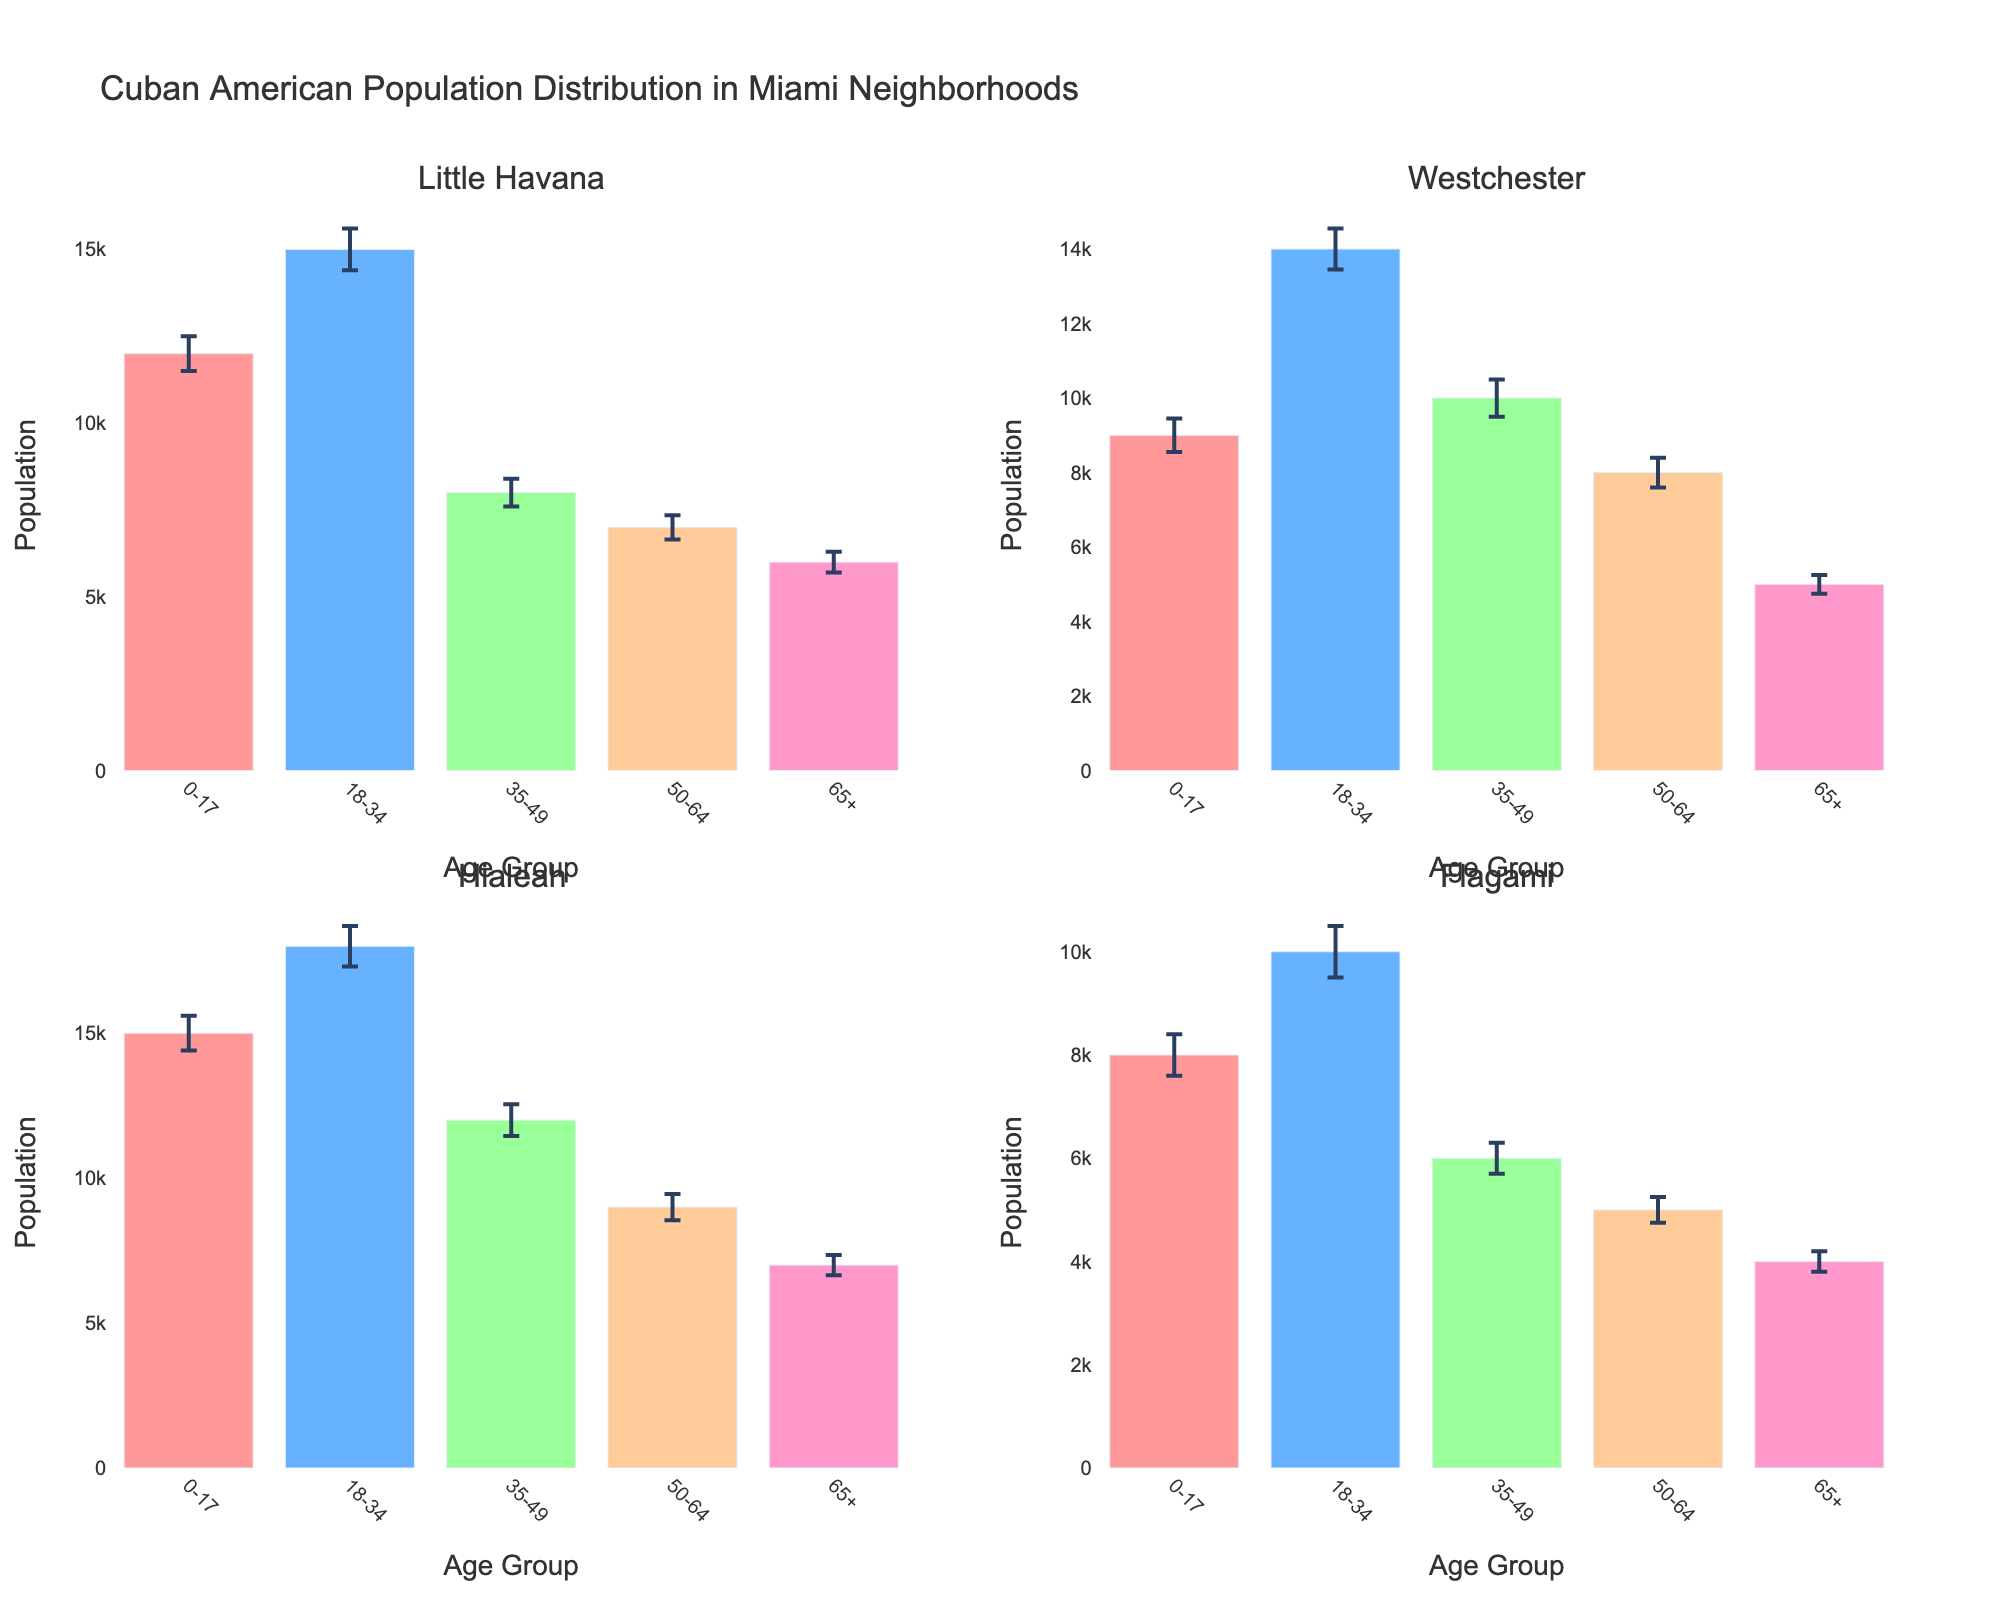what is the population of Little Havana in the 18-34 age group? According to the bar in the subplot for Little Havana, the population for the 18-34 age group is listed.
Answer: 15000 What neighborhood has the highest population for the 0-17 age group? By comparing the heights of the bars for the 0-17 age group across all subplots, the tallest bar represents the highest population.
Answer: Hialeah Which age group in Westchester has the lowest population? By observing the Westchester subplot, identify the shortest bar, which represents the age group with the lowest population.
Answer: 65+ How does the population of the 50-64 age group in Flagami compare to that in Little Havana? Compare the heights of the bars for the 50-64 age group in the subplots for Flagami and Little Havana.
Answer: Less What is the combined population of the 35-49 age group across all neighborhoods? Add the populations for the 35-49 age group from each subplot: Little Havana (8000), Westchester (10000), Hialeah (12000), and Flagami (6000). The sum is 8000 + 10000 + 12000 + 6000.
Answer: 36000 What is the average population of the 18-34 age group across all neighborhoods? Calculate the total population for the 18-34 age group (15000 from Little Havana, 14000 from Westchester, 18000 from Hialeah, and 10000 from Flagami) and then divide by the number of neighborhoods (4). The total is 57000, so the average is 57000 / 4.
Answer: 14250 Which neighborhood has the smallest standard deviation for the 65+ age group? Look at the error bars for the 65+ age group in each subplot and identify the smallest standard deviation.
Answer: Flagami In which neighborhood is the population of the 18-34 age group at least 1.5 times greater than that of the 65+ age group? Compare the population of the 18-34 and 65+ age groups in each neighborhood to see which meets the condition (1.5 * 65+). Only include neighborhoods that satisfy this ratio.
Answer: Hialeah How much greater is the population of the 35-49 age group in Hialeah compared to Westchester? Subtract the population of the 35-49 age group in Westchester (10000) from that in Hialeah (12000). The calculation results in 12000 - 10000.
Answer: 2000 Which age group shows the highest variance in population across all neighborhoods? Variance can be inferred by comparing the lengths of the error bars across subplots for each age group. The age group with the longest error bars generally has the highest variance.
Answer: 18-34 